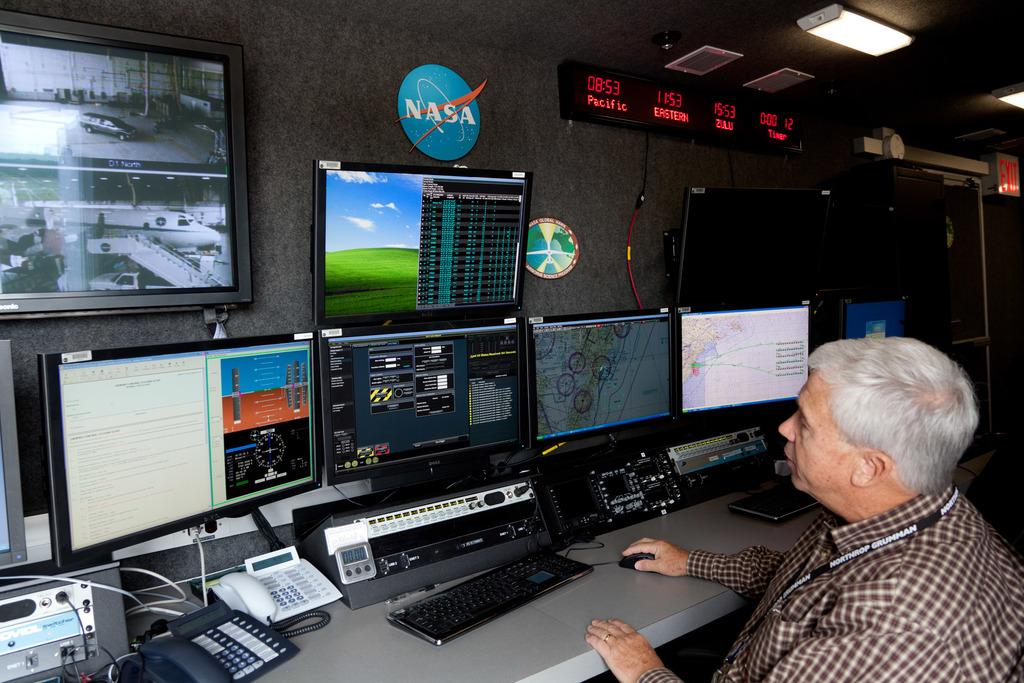<image>
Summarize the visual content of the image. A man in a control room with several screens and a NASA logo on the wall. 